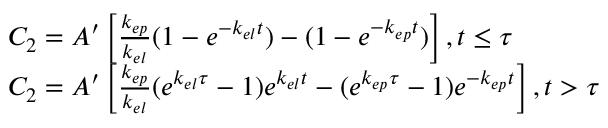<formula> <loc_0><loc_0><loc_500><loc_500>\begin{array} { r l } & { C _ { 2 } = A ^ { \prime } \left [ \frac { k _ { e p } } { k _ { e l } } ( 1 - e ^ { - k _ { e l } t } ) - ( 1 - e ^ { - k _ { e p } t } ) \right ] , t \leq \tau } \\ & { C _ { 2 } = A ^ { \prime } \left [ \frac { k _ { e p } } { k _ { e l } } ( e ^ { k _ { e l } \tau } - 1 ) e ^ { k _ { e l } t } - ( e ^ { k _ { e p } \tau } - 1 ) e ^ { - k _ { e p } t } \right ] , t > \tau } \end{array}</formula> 